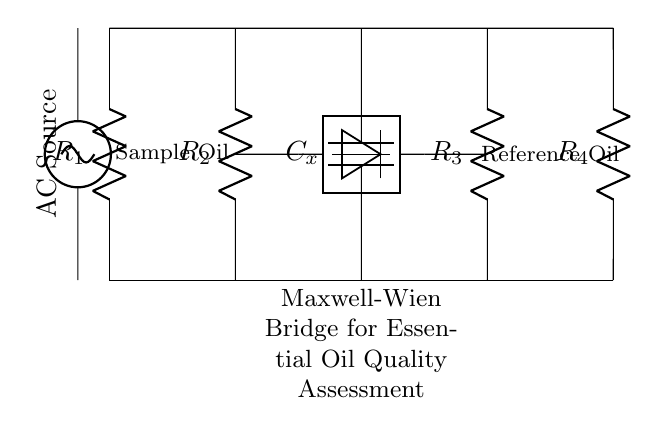What type of circuit is this? This circuit is a Maxwell-Wien bridge, which is specifically designed for measuring the quality and purity of materials, in this case, essential oils. The components and configuration are characteristic of this type of bridge.
Answer: Maxwell-Wien bridge What components are used in the circuit? The circuit includes four resistors (R1, R2, R3, R4) and one capacitor (C_x). These components are critical in creating the balance necessary for the bridge to function correctly in assessing the oils.
Answer: Four resistors and one capacitor What does the AC source do in this circuit? The AC source provides alternating current necessary for operating the bridge, allowing it to measure impedance changes of the oils being tested. This alternating nature is essential for the bridge to provide accurate readings.
Answer: Provides alternating current Where is the sample oil placed in the circuit? The sample oil is connected to R2, which is positioned between the AC source and the detector, indicating that the oil being tested directly influences this part of the bridge.
Answer: Connected to R2 What is the purpose of the detector in the circuit? The detector measures the current or voltage difference that indicates whether the bridge is balanced. This balance is essential for determining the quality of the sample oil against the reference oil with precision.
Answer: Measure current/voltage difference If the bridge is balanced, what does this indicate about the oils? A balanced bridge indicates that the impedance of the sample oil and the reference oil are equal, suggesting that the quality and purity of the oils are comparable or the same.
Answer: Impedance equality How many resistors are in the bridge, and what role do they play? There are four resistors, and they provide the necessary resistance values to balance the bridge. Each resistor interacts with the sample and reference oils to assess their properties effectively.
Answer: Four resistors 